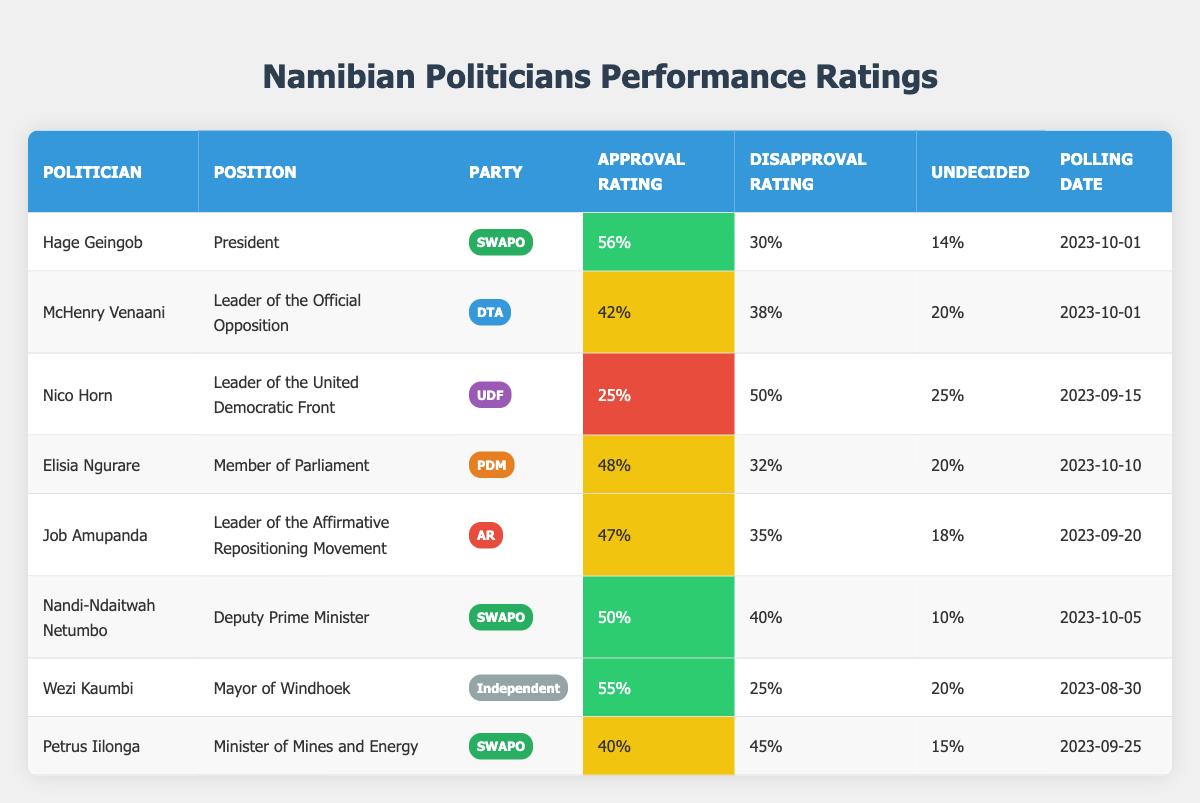What is the approval rating of Hage Geingob? The table shows that Hage Geingob has an approval rating of 56%.
Answer: 56% Which politician has the highest disapproval rating? By comparing the disapproval ratings, Nico Horn has the highest at 50%.
Answer: Nico Horn What percentage of the respondents were undecided about McHenry Venaani? The table indicates that 20% of the respondents were undecided regarding McHenry Venaani.
Answer: 20% How many politicians have an approval rating above 50%? Hage Geingob (56%), Wezi Kaumbi (55%), and Nandi-Ndaitwah Netumbo (50%) have approval ratings above 50%. Therefore, there are 3 politicians.
Answer: 3 Is the approval rating of Job Amupanda higher than that of Petrus Iilonga? Job Amupanda has a 47% approval rating, while Petrus Iilonga has a 40% rating. Since 47% is greater than 40%, the statement is true.
Answer: Yes What is the average approval rating of politicians from SWAPO? The approval ratings of SWAPO politicians are 56%, 50%, and 40%. Summing them gives 146%. Dividing by 3 (the number of SWAPO politicians) gives an average of 48.67%.
Answer: 48.67% Which party has the least approval rating based on the table? The United Democratic Front (UDF) represented by Nico Horn has the least approval rating at 25%.
Answer: UDF What is the difference in approval ratings between Elisia Ngurare and Nandi-Ndaitwah Netumbo? Elisia Ngurare has an approval rating of 48%, while Nandi-Ndaitwah Netumbo has an approval rating of 50%. The difference is 50% - 48% = 2%.
Answer: 2% Are there more politicians with disapproval ratings above 40% than below? The table shows three politicians (Petrus Iilonga, Nico Horn, and Nandi-Ndaitwah Netumbo) with disapproval ratings above 40%. There are four with ratings 40% and below (Hage Geingob, Elisia Ngurare, Job Amupanda, and Wezi Kaumbi), so there are more below 40%.
Answer: No Who is the only independent politician listed, and what is their approval rating? Wezi Kaumbi is the only independent politician and has an approval rating of 55%.
Answer: Wezi Kaumbi, 55% 